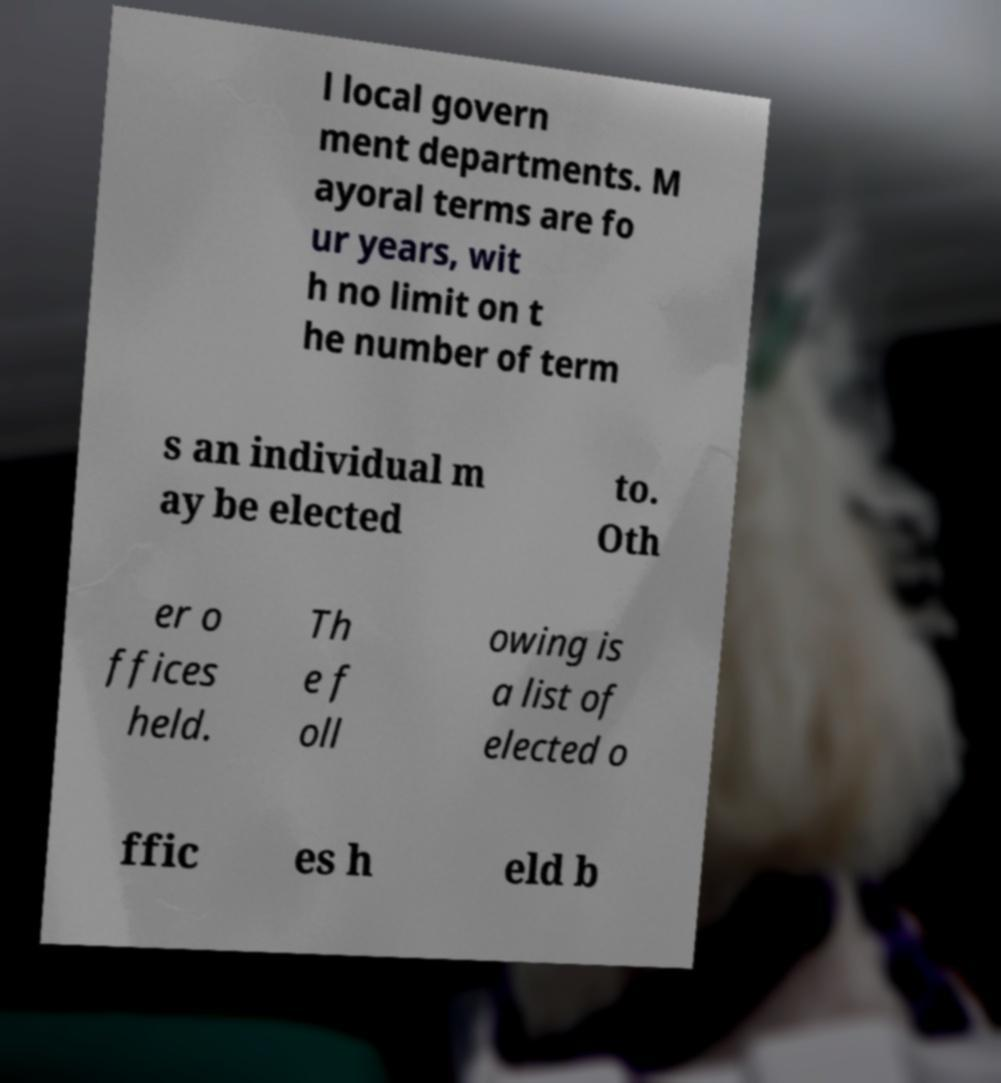I need the written content from this picture converted into text. Can you do that? l local govern ment departments. M ayoral terms are fo ur years, wit h no limit on t he number of term s an individual m ay be elected to. Oth er o ffices held. Th e f oll owing is a list of elected o ffic es h eld b 